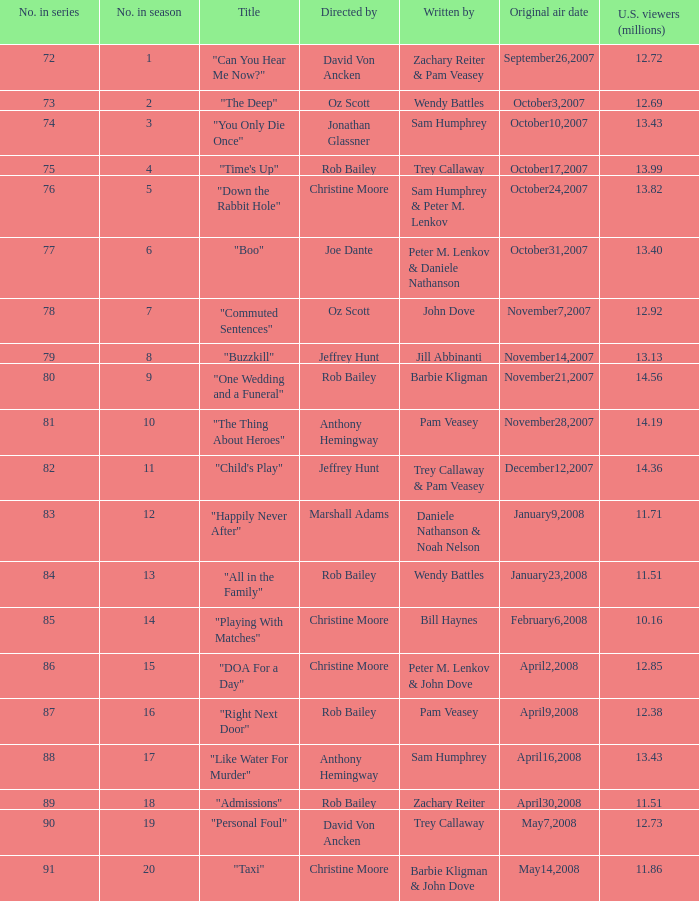How many millions of u.s. watchers viewed the episode "buzzkill"? 1.0. 